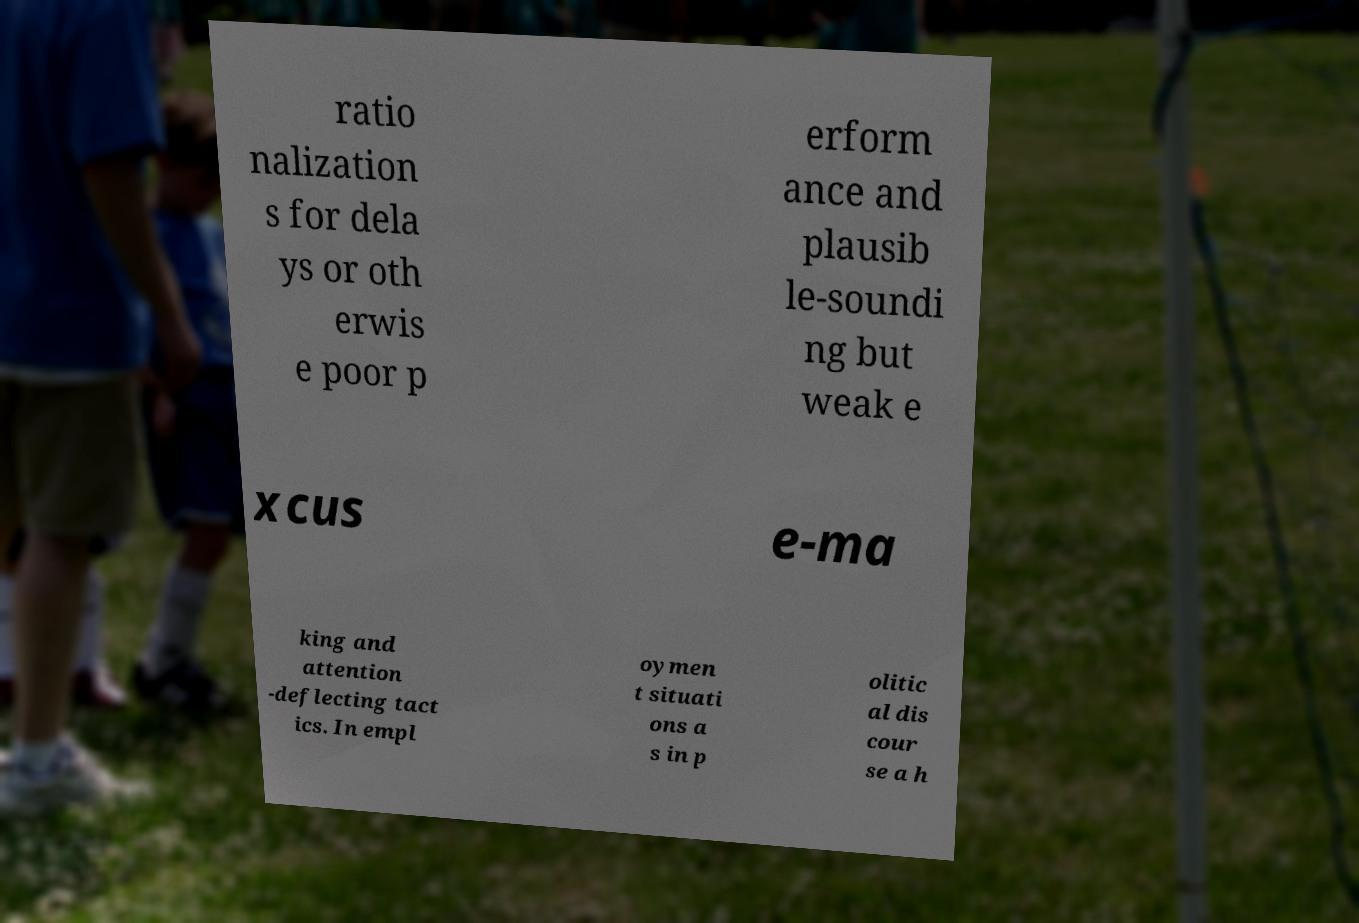Please identify and transcribe the text found in this image. ratio nalization s for dela ys or oth erwis e poor p erform ance and plausib le-soundi ng but weak e xcus e-ma king and attention -deflecting tact ics. In empl oymen t situati ons a s in p olitic al dis cour se a h 